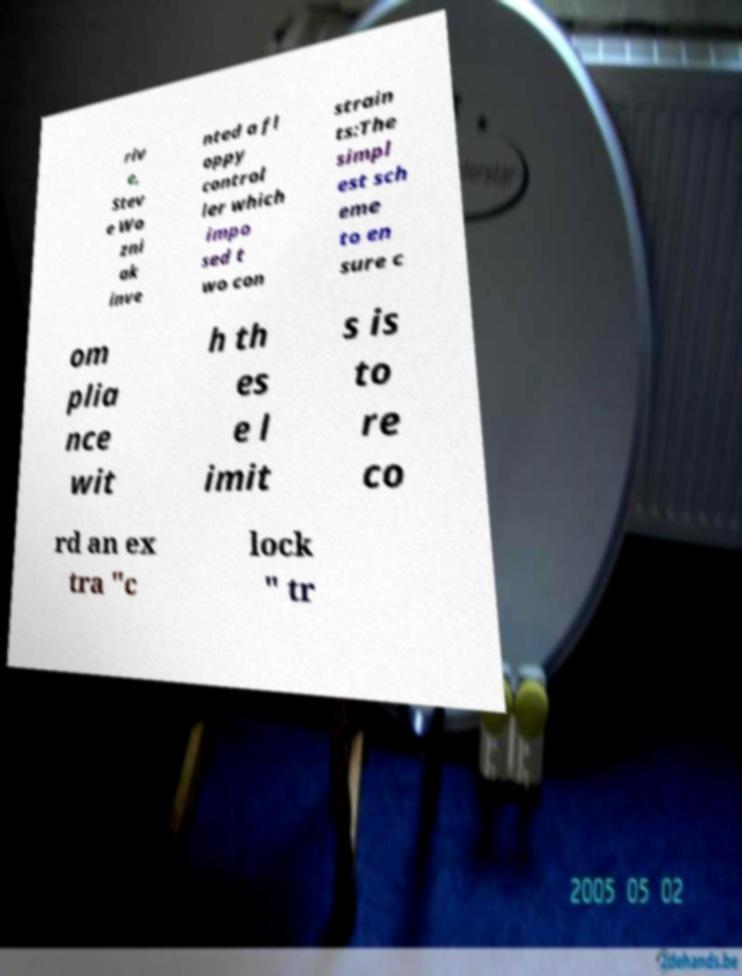What messages or text are displayed in this image? I need them in a readable, typed format. riv e, Stev e Wo zni ak inve nted a fl oppy control ler which impo sed t wo con strain ts:The simpl est sch eme to en sure c om plia nce wit h th es e l imit s is to re co rd an ex tra "c lock " tr 